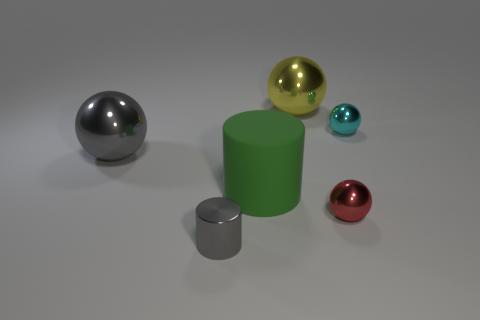There is a ball that is left of the green cylinder left of the tiny red thing; how big is it?
Ensure brevity in your answer.  Large. Is the number of big yellow spheres on the left side of the cyan metal object greater than the number of large green things?
Your response must be concise. No. Is the size of the gray thing behind the green object the same as the small red metal ball?
Offer a terse response. No. The shiny sphere that is both to the left of the red shiny object and behind the big gray shiny ball is what color?
Your answer should be compact. Yellow. There is a gray object that is the same size as the yellow ball; what shape is it?
Keep it short and to the point. Sphere. Are there any small metallic cylinders of the same color as the big rubber thing?
Keep it short and to the point. No. Is the number of green things to the right of the small red metal ball the same as the number of small purple metallic spheres?
Your response must be concise. Yes. Does the tiny metallic cylinder have the same color as the rubber cylinder?
Give a very brief answer. No. How big is the shiny thing that is both in front of the tiny cyan thing and behind the red thing?
Keep it short and to the point. Large. The big thing that is the same material as the large yellow sphere is what color?
Ensure brevity in your answer.  Gray. 